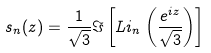<formula> <loc_0><loc_0><loc_500><loc_500>s _ { n } ( z ) = \frac { 1 } { \sqrt { 3 } } \Im \left [ L i _ { n } \left ( \frac { e ^ { i z } } { \sqrt { 3 } } \right ) \right ]</formula> 